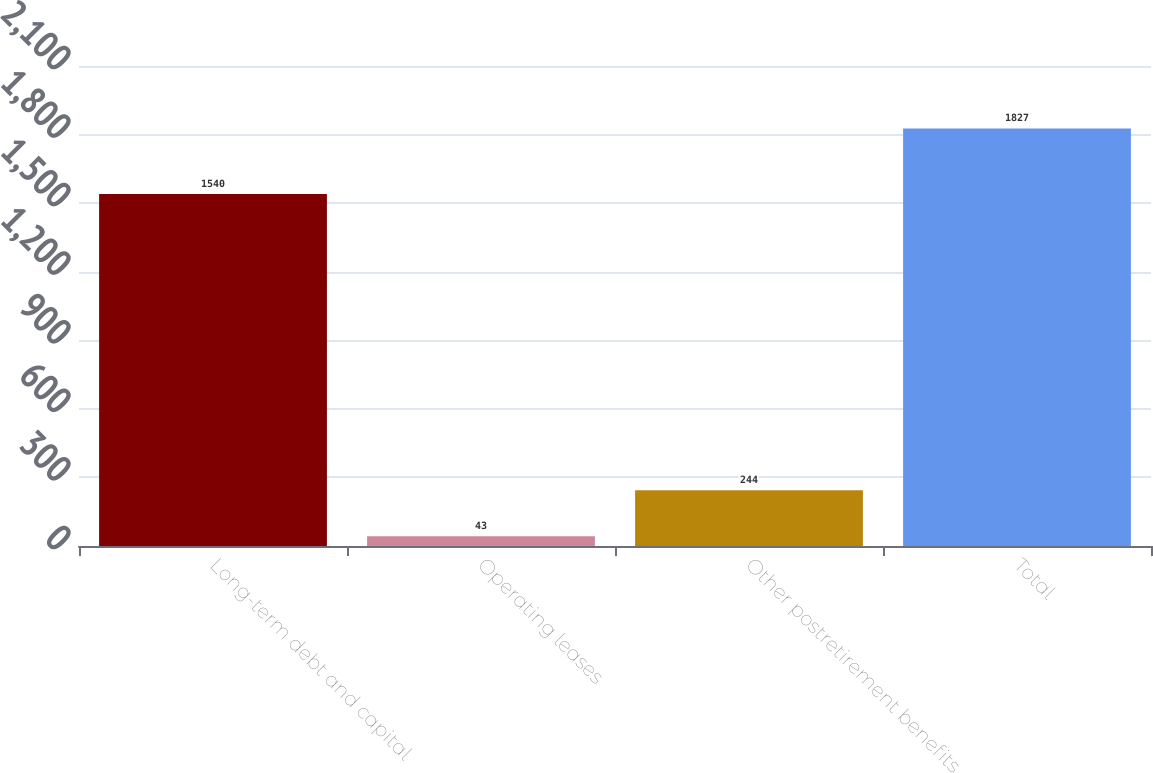Convert chart. <chart><loc_0><loc_0><loc_500><loc_500><bar_chart><fcel>Long-term debt and capital<fcel>Operating leases<fcel>Other postretirement benefits<fcel>Total<nl><fcel>1540<fcel>43<fcel>244<fcel>1827<nl></chart> 